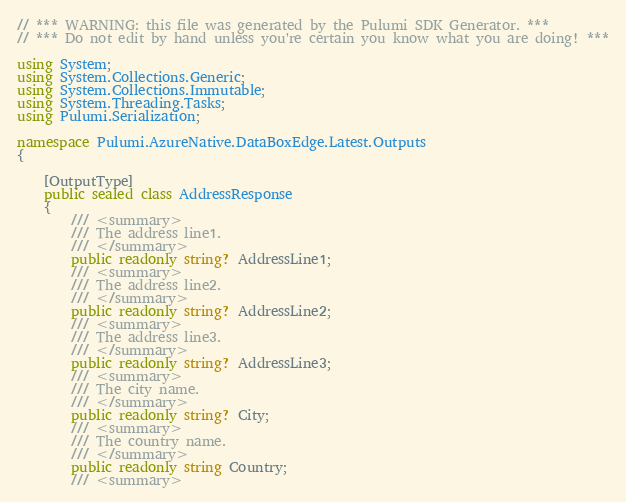Convert code to text. <code><loc_0><loc_0><loc_500><loc_500><_C#_>// *** WARNING: this file was generated by the Pulumi SDK Generator. ***
// *** Do not edit by hand unless you're certain you know what you are doing! ***

using System;
using System.Collections.Generic;
using System.Collections.Immutable;
using System.Threading.Tasks;
using Pulumi.Serialization;

namespace Pulumi.AzureNative.DataBoxEdge.Latest.Outputs
{

    [OutputType]
    public sealed class AddressResponse
    {
        /// <summary>
        /// The address line1.
        /// </summary>
        public readonly string? AddressLine1;
        /// <summary>
        /// The address line2.
        /// </summary>
        public readonly string? AddressLine2;
        /// <summary>
        /// The address line3.
        /// </summary>
        public readonly string? AddressLine3;
        /// <summary>
        /// The city name.
        /// </summary>
        public readonly string? City;
        /// <summary>
        /// The country name.
        /// </summary>
        public readonly string Country;
        /// <summary></code> 